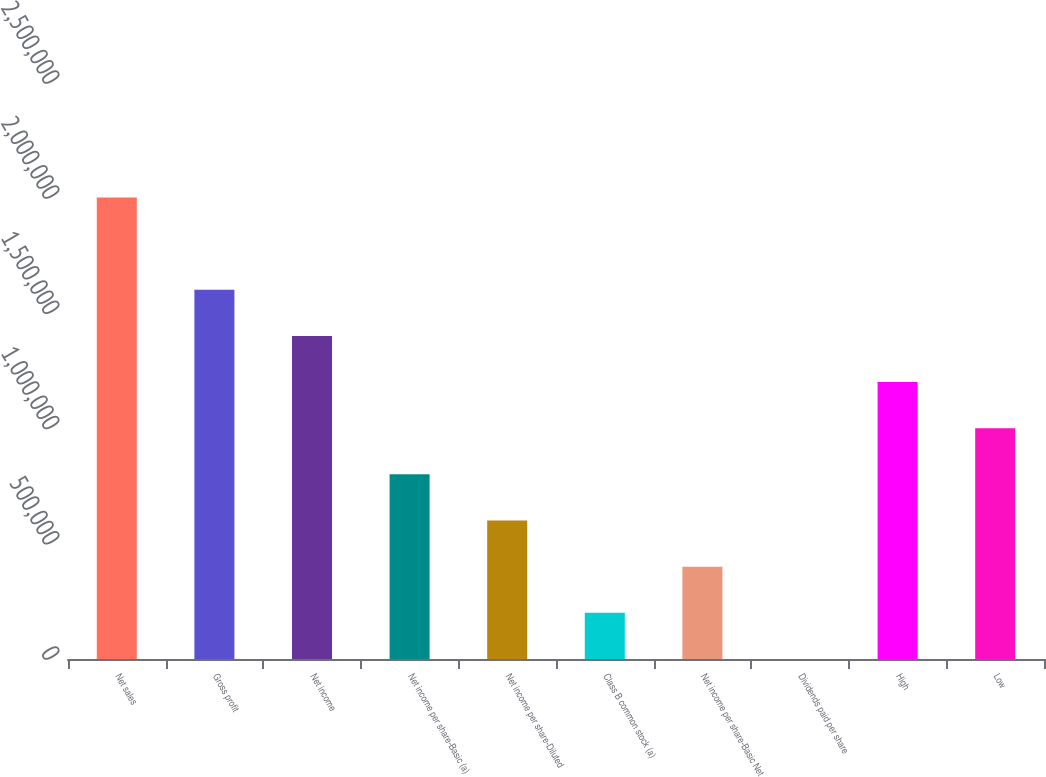Convert chart. <chart><loc_0><loc_0><loc_500><loc_500><bar_chart><fcel>Net sales<fcel>Gross profit<fcel>Net income<fcel>Net income per share-Basic (a)<fcel>Net income per share-Diluted<fcel>Class B common stock (a)<fcel>Net income per share-Basic Net<fcel>Dividends paid per share<fcel>High<fcel>Low<nl><fcel>2.00345e+06<fcel>1.60276e+06<fcel>1.40242e+06<fcel>801382<fcel>601037<fcel>200346<fcel>400691<fcel>0.56<fcel>1.20207e+06<fcel>1.00173e+06<nl></chart> 